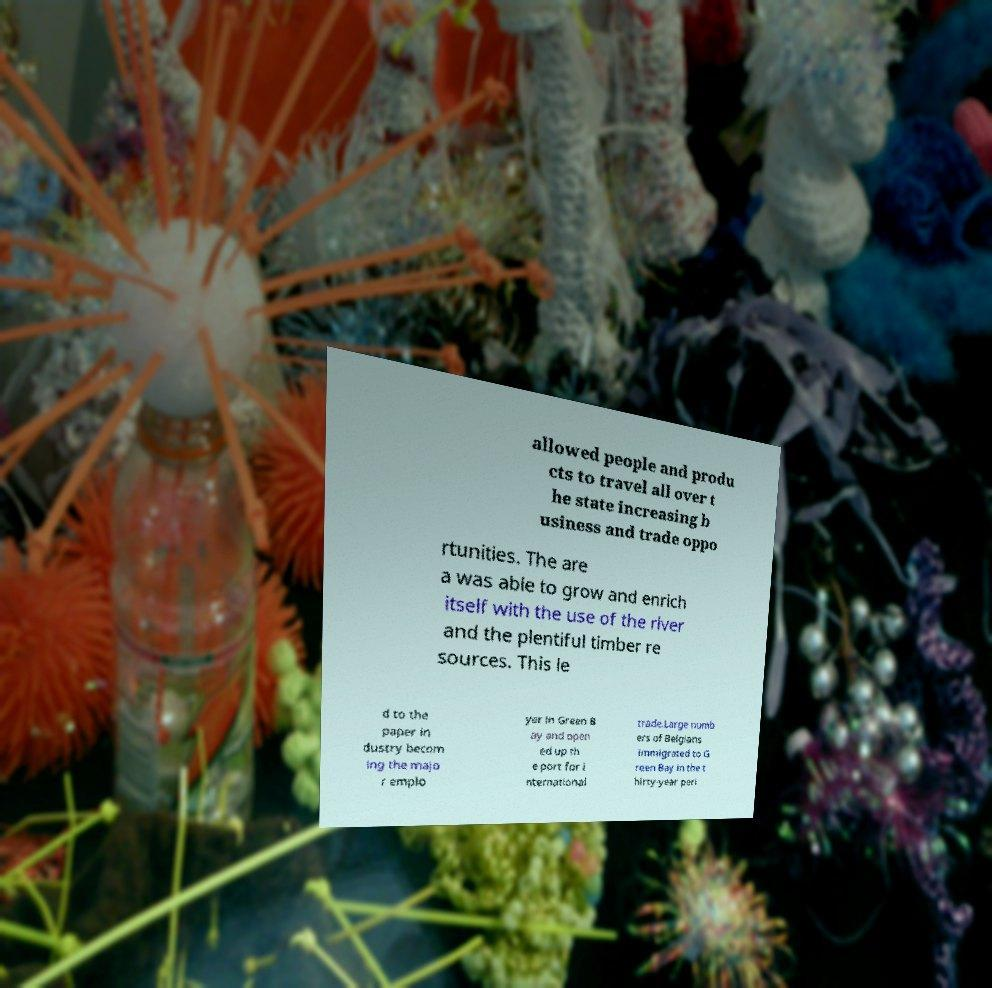Can you read and provide the text displayed in the image?This photo seems to have some interesting text. Can you extract and type it out for me? allowed people and produ cts to travel all over t he state increasing b usiness and trade oppo rtunities. The are a was able to grow and enrich itself with the use of the river and the plentiful timber re sources. This le d to the paper in dustry becom ing the majo r emplo yer in Green B ay and open ed up th e port for i nternational trade.Large numb ers of Belgians immigrated to G reen Bay in the t hirty-year peri 